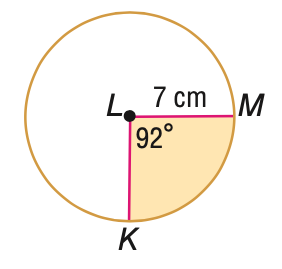Question: Find the area of the shaded sector. Round to the nearest tenth.
Choices:
A. 32.7
B. 39.3
C. 114.6
D. 153.9
Answer with the letter. Answer: B 